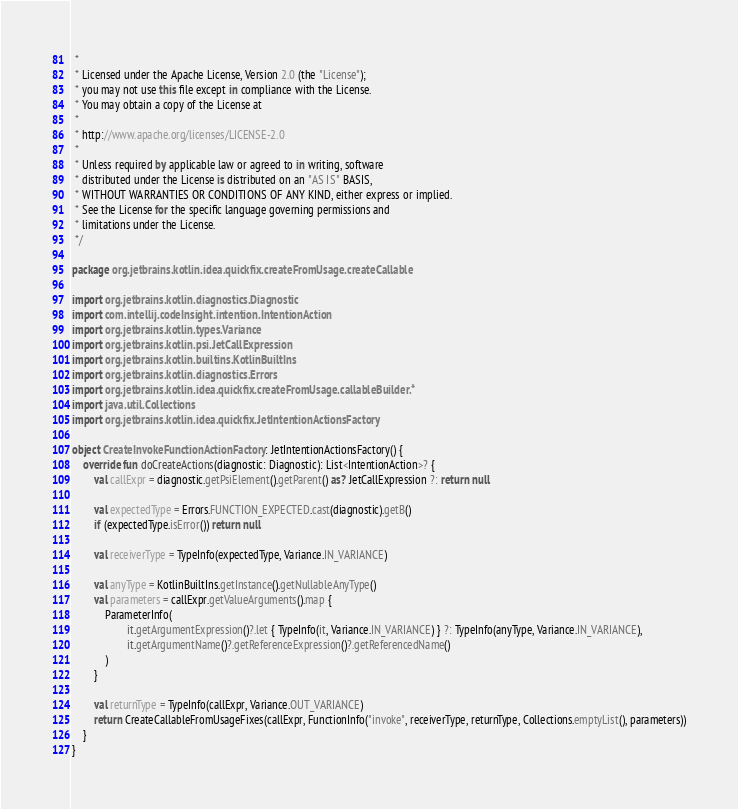Convert code to text. <code><loc_0><loc_0><loc_500><loc_500><_Kotlin_> *
 * Licensed under the Apache License, Version 2.0 (the "License");
 * you may not use this file except in compliance with the License.
 * You may obtain a copy of the License at
 *
 * http://www.apache.org/licenses/LICENSE-2.0
 *
 * Unless required by applicable law or agreed to in writing, software
 * distributed under the License is distributed on an "AS IS" BASIS,
 * WITHOUT WARRANTIES OR CONDITIONS OF ANY KIND, either express or implied.
 * See the License for the specific language governing permissions and
 * limitations under the License.
 */

package org.jetbrains.kotlin.idea.quickfix.createFromUsage.createCallable

import org.jetbrains.kotlin.diagnostics.Diagnostic
import com.intellij.codeInsight.intention.IntentionAction
import org.jetbrains.kotlin.types.Variance
import org.jetbrains.kotlin.psi.JetCallExpression
import org.jetbrains.kotlin.builtins.KotlinBuiltIns
import org.jetbrains.kotlin.diagnostics.Errors
import org.jetbrains.kotlin.idea.quickfix.createFromUsage.callableBuilder.*
import java.util.Collections
import org.jetbrains.kotlin.idea.quickfix.JetIntentionActionsFactory

object CreateInvokeFunctionActionFactory : JetIntentionActionsFactory() {
    override fun doCreateActions(diagnostic: Diagnostic): List<IntentionAction>? {
        val callExpr = diagnostic.getPsiElement().getParent() as? JetCallExpression ?: return null

        val expectedType = Errors.FUNCTION_EXPECTED.cast(diagnostic).getB()
        if (expectedType.isError()) return null

        val receiverType = TypeInfo(expectedType, Variance.IN_VARIANCE)

        val anyType = KotlinBuiltIns.getInstance().getNullableAnyType()
        val parameters = callExpr.getValueArguments().map {
            ParameterInfo(
                    it.getArgumentExpression()?.let { TypeInfo(it, Variance.IN_VARIANCE) } ?: TypeInfo(anyType, Variance.IN_VARIANCE),
                    it.getArgumentName()?.getReferenceExpression()?.getReferencedName()
            )
        }

        val returnType = TypeInfo(callExpr, Variance.OUT_VARIANCE)
        return CreateCallableFromUsageFixes(callExpr, FunctionInfo("invoke", receiverType, returnType, Collections.emptyList(), parameters))
    }
}
</code> 